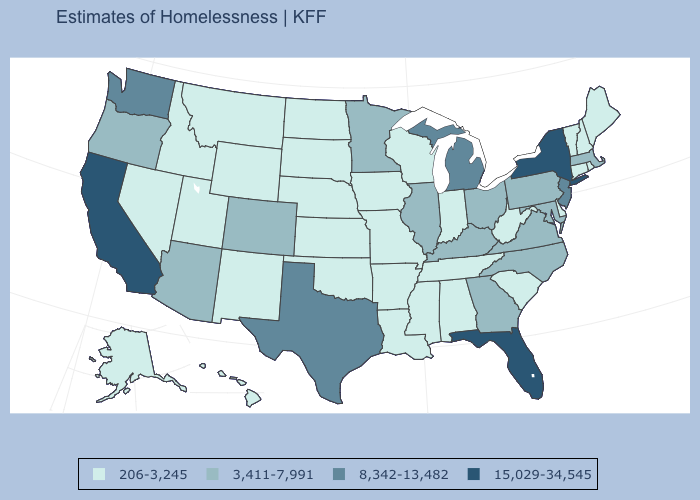Does New York have the highest value in the USA?
Quick response, please. Yes. How many symbols are there in the legend?
Concise answer only. 4. Among the states that border Virginia , which have the highest value?
Answer briefly. Kentucky, Maryland, North Carolina. Does Mississippi have the same value as Pennsylvania?
Short answer required. No. What is the lowest value in the USA?
Answer briefly. 206-3,245. What is the lowest value in the USA?
Give a very brief answer. 206-3,245. Name the states that have a value in the range 206-3,245?
Concise answer only. Alabama, Alaska, Arkansas, Connecticut, Delaware, Hawaii, Idaho, Indiana, Iowa, Kansas, Louisiana, Maine, Mississippi, Missouri, Montana, Nebraska, Nevada, New Hampshire, New Mexico, North Dakota, Oklahoma, Rhode Island, South Carolina, South Dakota, Tennessee, Utah, Vermont, West Virginia, Wisconsin, Wyoming. What is the value of New Mexico?
Concise answer only. 206-3,245. What is the value of Colorado?
Give a very brief answer. 3,411-7,991. Does Maryland have the highest value in the USA?
Be succinct. No. Does Connecticut have the highest value in the USA?
Keep it brief. No. What is the value of Massachusetts?
Quick response, please. 3,411-7,991. What is the value of Tennessee?
Keep it brief. 206-3,245. Does New York have the highest value in the USA?
Concise answer only. Yes. Name the states that have a value in the range 15,029-34,545?
Give a very brief answer. California, Florida, New York. 